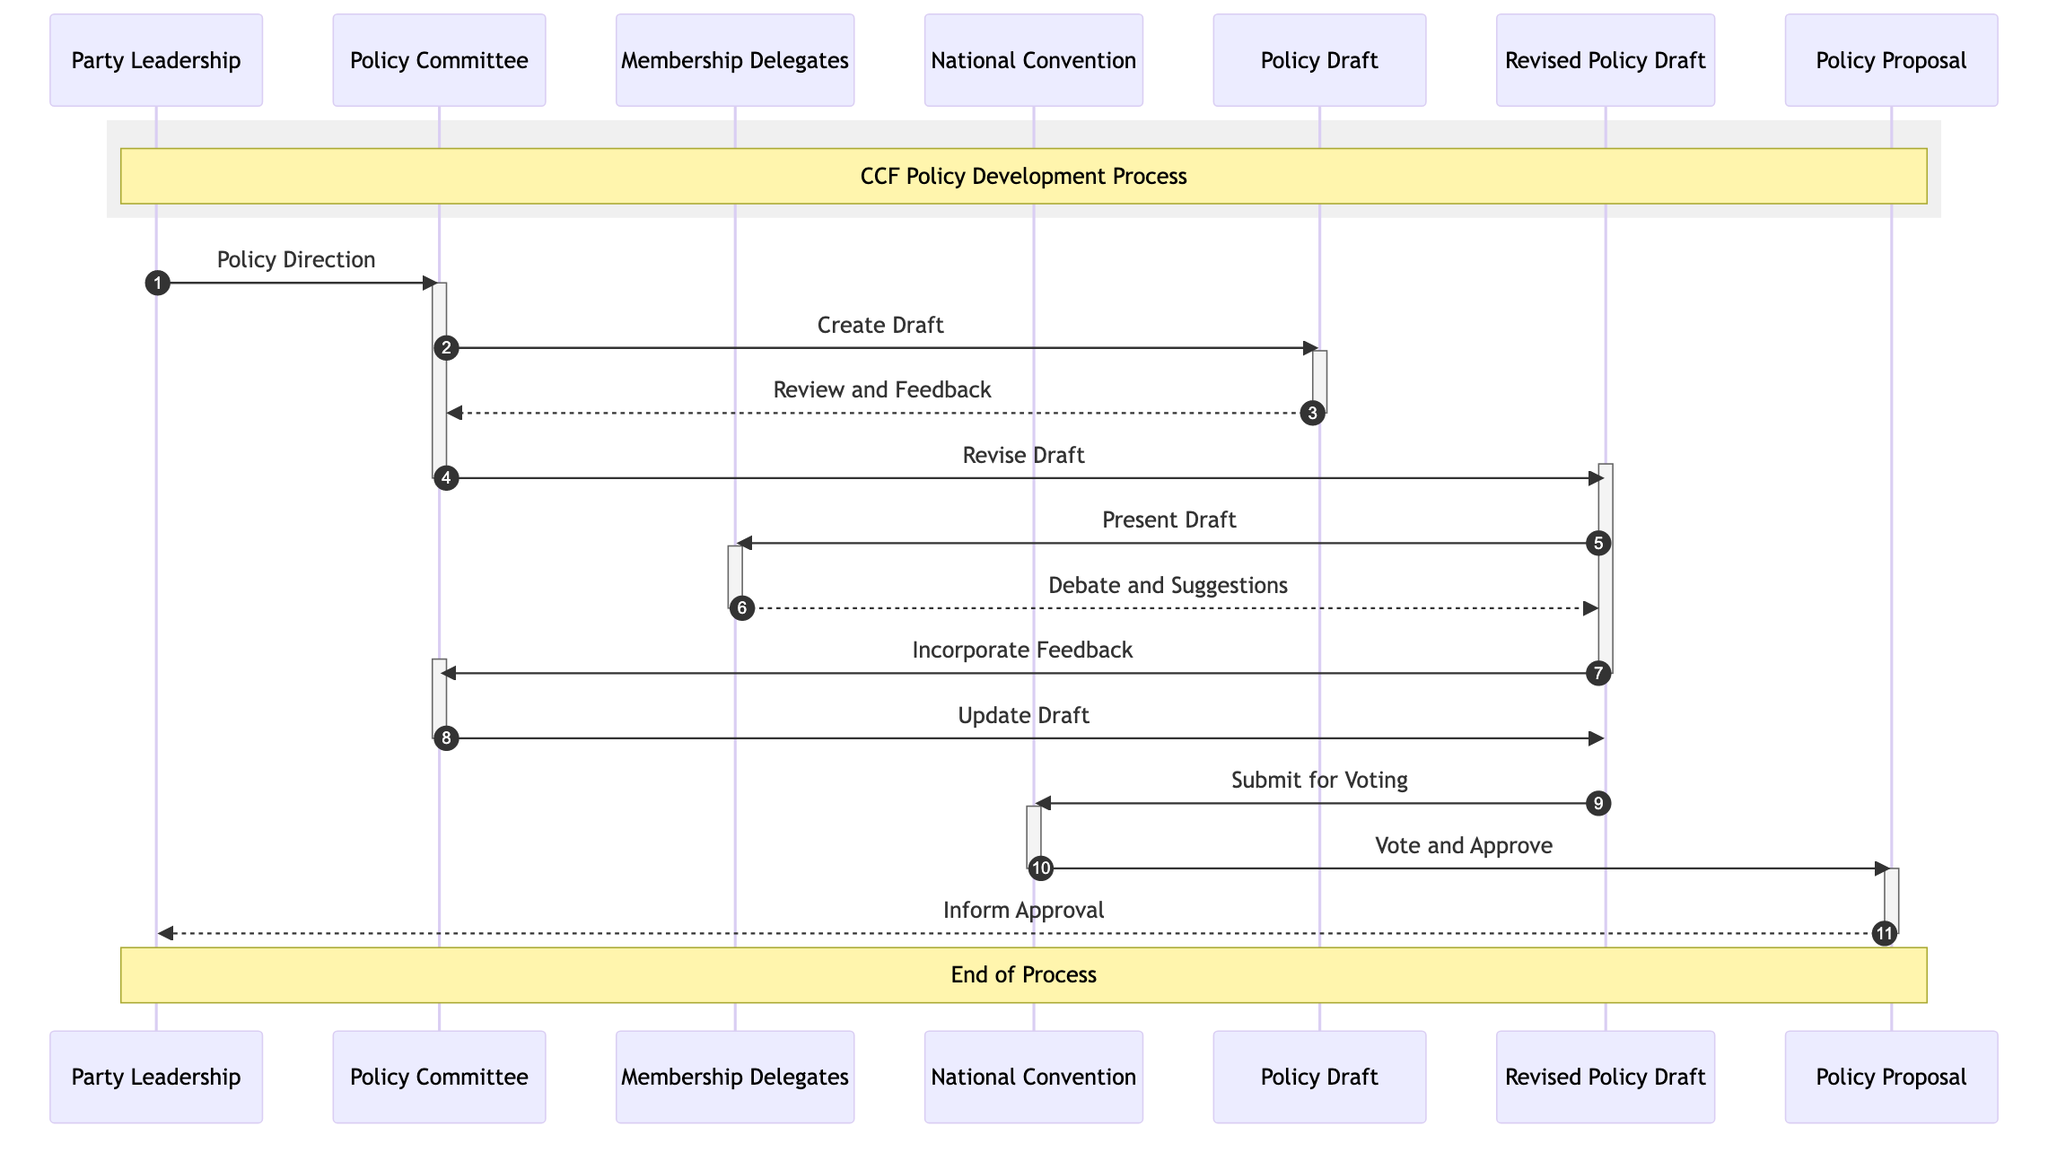What are the roles of the actors in this diagram? The diagram shows four actors: Party Leadership (strategize and approve policies), Policy Committee (develop and draft policy proposals), Membership Delegates (discuss and debate policy proposals), and National Convention (vote on policy proposals).
Answer: Party Leadership, Policy Committee, Membership Delegates, National Convention How many messages are exchanged in this sequence? The diagram presents ten distinct messages exchanged between various nodes, illustrating the progression of policy development.
Answer: Ten Who creates the initial policy draft? According to the diagram, the Policy Committee is responsible for creating the initial policy draft after receiving the policy direction from the Party Leadership.
Answer: Policy Committee What happens after the Membership Delegates debate the revised policy draft? Following the debate, the revised policy draft is sent back to the Policy Committee for incorporating feedback based on the suggestions from the Membership Delegates.
Answer: Incorporate Feedback At what point does the National Convention approve the policy proposal? The National Convention votes on the policy proposal after receiving the revised policy draft submitted for voting, marking the culmination of the process.
Answer: Vote and Approve Which object represents the final version of the policy proposal? The object labeled "Policy Proposal" represents the final approved version of the policy proposal that is presented after the voting by the National Convention.
Answer: Policy Proposal What role does the Party Leadership play at the end of the process? At the conclusion of the policy development process, the Party Leadership is informed of the approval of the policy proposal, signifying their oversight role in the final stages.
Answer: Inform Approval How does the Policy Committee revise the draft? After receiving feedback from the initial policy draft review, the Policy Committee revises the draft to incorporate this feedback before presenting it to the Membership Delegates.
Answer: Revise Draft When is the revised policy draft submitted for voting? The revised policy draft is submitted for voting once the Policy Committee has incorporated the feedback from the Membership Delegates after their debate on the draft.
Answer: Submit for Voting 